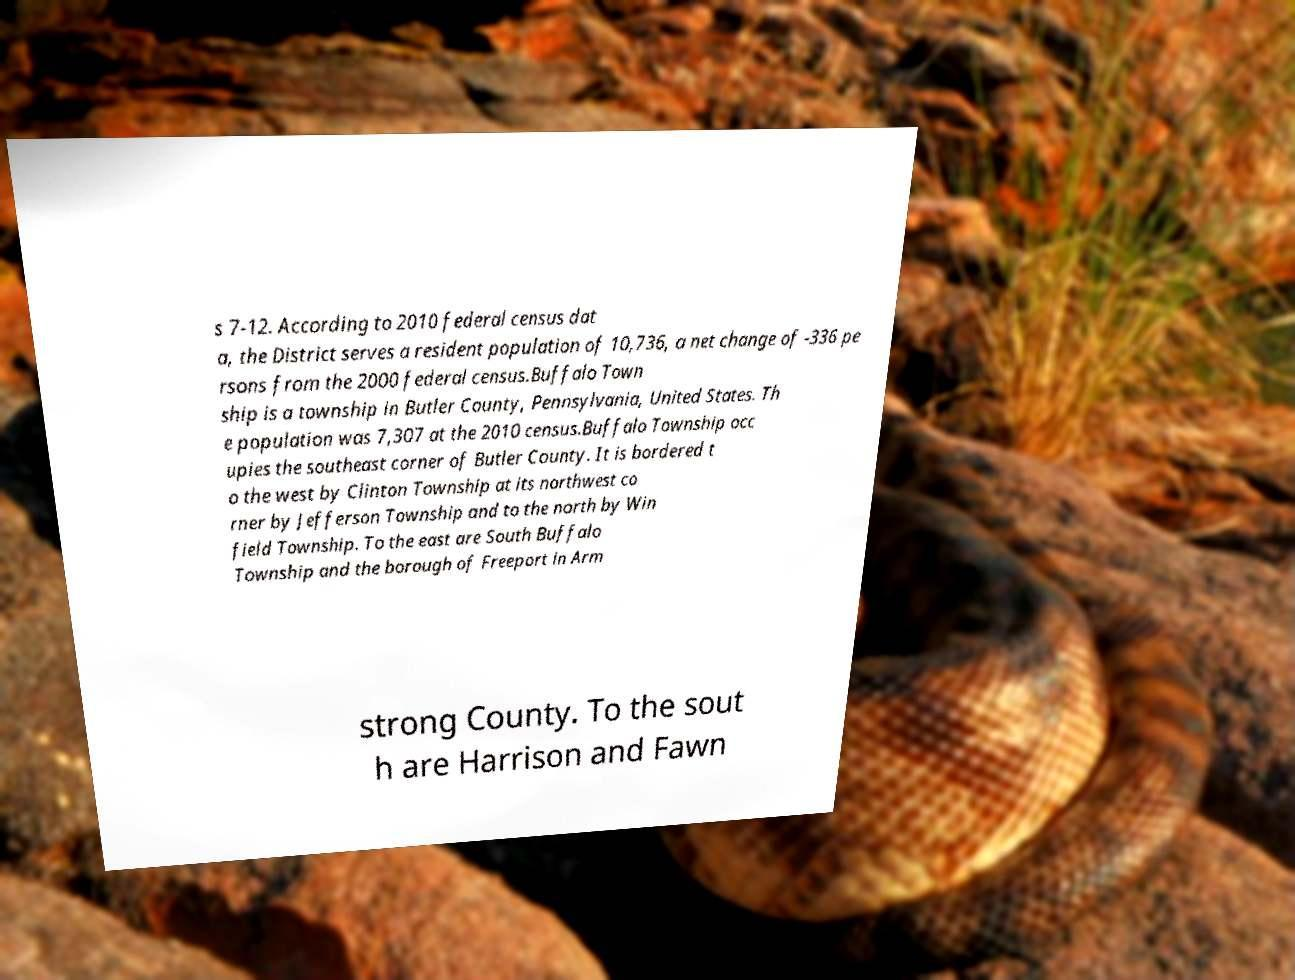What messages or text are displayed in this image? I need them in a readable, typed format. s 7-12. According to 2010 federal census dat a, the District serves a resident population of 10,736, a net change of -336 pe rsons from the 2000 federal census.Buffalo Town ship is a township in Butler County, Pennsylvania, United States. Th e population was 7,307 at the 2010 census.Buffalo Township occ upies the southeast corner of Butler County. It is bordered t o the west by Clinton Township at its northwest co rner by Jefferson Township and to the north by Win field Township. To the east are South Buffalo Township and the borough of Freeport in Arm strong County. To the sout h are Harrison and Fawn 